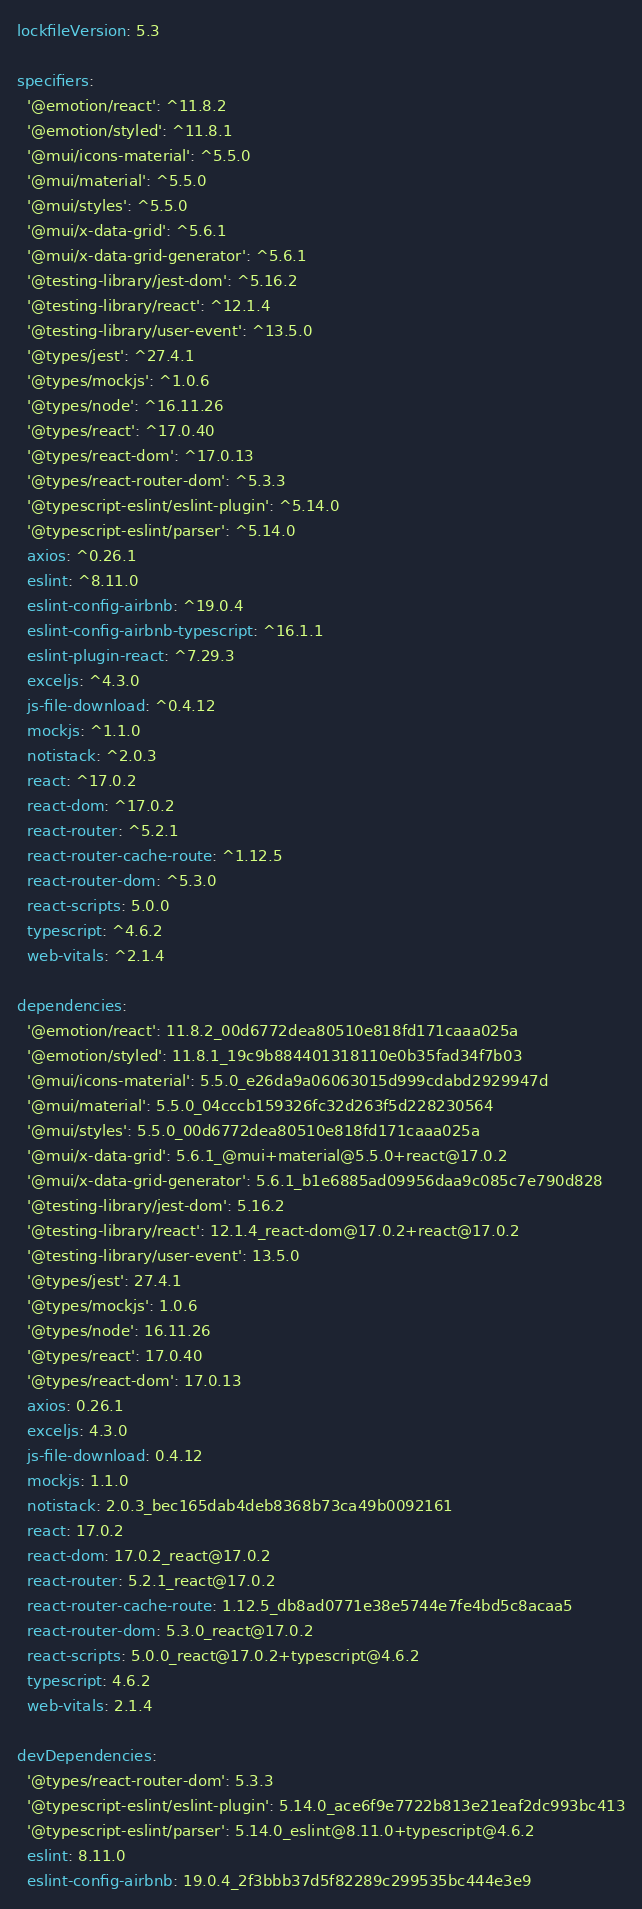Convert code to text. <code><loc_0><loc_0><loc_500><loc_500><_YAML_>lockfileVersion: 5.3

specifiers:
  '@emotion/react': ^11.8.2
  '@emotion/styled': ^11.8.1
  '@mui/icons-material': ^5.5.0
  '@mui/material': ^5.5.0
  '@mui/styles': ^5.5.0
  '@mui/x-data-grid': ^5.6.1
  '@mui/x-data-grid-generator': ^5.6.1
  '@testing-library/jest-dom': ^5.16.2
  '@testing-library/react': ^12.1.4
  '@testing-library/user-event': ^13.5.0
  '@types/jest': ^27.4.1
  '@types/mockjs': ^1.0.6
  '@types/node': ^16.11.26
  '@types/react': ^17.0.40
  '@types/react-dom': ^17.0.13
  '@types/react-router-dom': ^5.3.3
  '@typescript-eslint/eslint-plugin': ^5.14.0
  '@typescript-eslint/parser': ^5.14.0
  axios: ^0.26.1
  eslint: ^8.11.0
  eslint-config-airbnb: ^19.0.4
  eslint-config-airbnb-typescript: ^16.1.1
  eslint-plugin-react: ^7.29.3
  exceljs: ^4.3.0
  js-file-download: ^0.4.12
  mockjs: ^1.1.0
  notistack: ^2.0.3
  react: ^17.0.2
  react-dom: ^17.0.2
  react-router: ^5.2.1
  react-router-cache-route: ^1.12.5
  react-router-dom: ^5.3.0
  react-scripts: 5.0.0
  typescript: ^4.6.2
  web-vitals: ^2.1.4

dependencies:
  '@emotion/react': 11.8.2_00d6772dea80510e818fd171caaa025a
  '@emotion/styled': 11.8.1_19c9b884401318110e0b35fad34f7b03
  '@mui/icons-material': 5.5.0_e26da9a06063015d999cdabd2929947d
  '@mui/material': 5.5.0_04cccb159326fc32d263f5d228230564
  '@mui/styles': 5.5.0_00d6772dea80510e818fd171caaa025a
  '@mui/x-data-grid': 5.6.1_@mui+material@5.5.0+react@17.0.2
  '@mui/x-data-grid-generator': 5.6.1_b1e6885ad09956daa9c085c7e790d828
  '@testing-library/jest-dom': 5.16.2
  '@testing-library/react': 12.1.4_react-dom@17.0.2+react@17.0.2
  '@testing-library/user-event': 13.5.0
  '@types/jest': 27.4.1
  '@types/mockjs': 1.0.6
  '@types/node': 16.11.26
  '@types/react': 17.0.40
  '@types/react-dom': 17.0.13
  axios: 0.26.1
  exceljs: 4.3.0
  js-file-download: 0.4.12
  mockjs: 1.1.0
  notistack: 2.0.3_bec165dab4deb8368b73ca49b0092161
  react: 17.0.2
  react-dom: 17.0.2_react@17.0.2
  react-router: 5.2.1_react@17.0.2
  react-router-cache-route: 1.12.5_db8ad0771e38e5744e7fe4bd5c8acaa5
  react-router-dom: 5.3.0_react@17.0.2
  react-scripts: 5.0.0_react@17.0.2+typescript@4.6.2
  typescript: 4.6.2
  web-vitals: 2.1.4

devDependencies:
  '@types/react-router-dom': 5.3.3
  '@typescript-eslint/eslint-plugin': 5.14.0_ace6f9e7722b813e21eaf2dc993bc413
  '@typescript-eslint/parser': 5.14.0_eslint@8.11.0+typescript@4.6.2
  eslint: 8.11.0
  eslint-config-airbnb: 19.0.4_2f3bbb37d5f82289c299535bc444e3e9</code> 